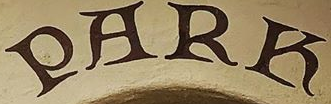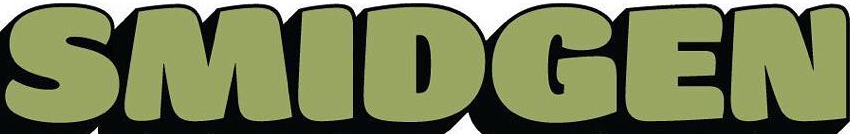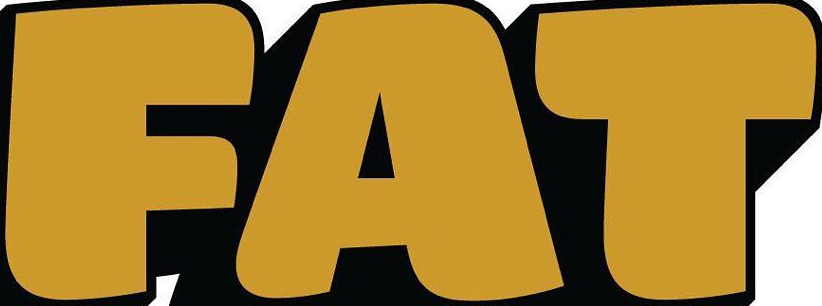What text appears in these images from left to right, separated by a semicolon? PARK; SMIDGEN; FAT 